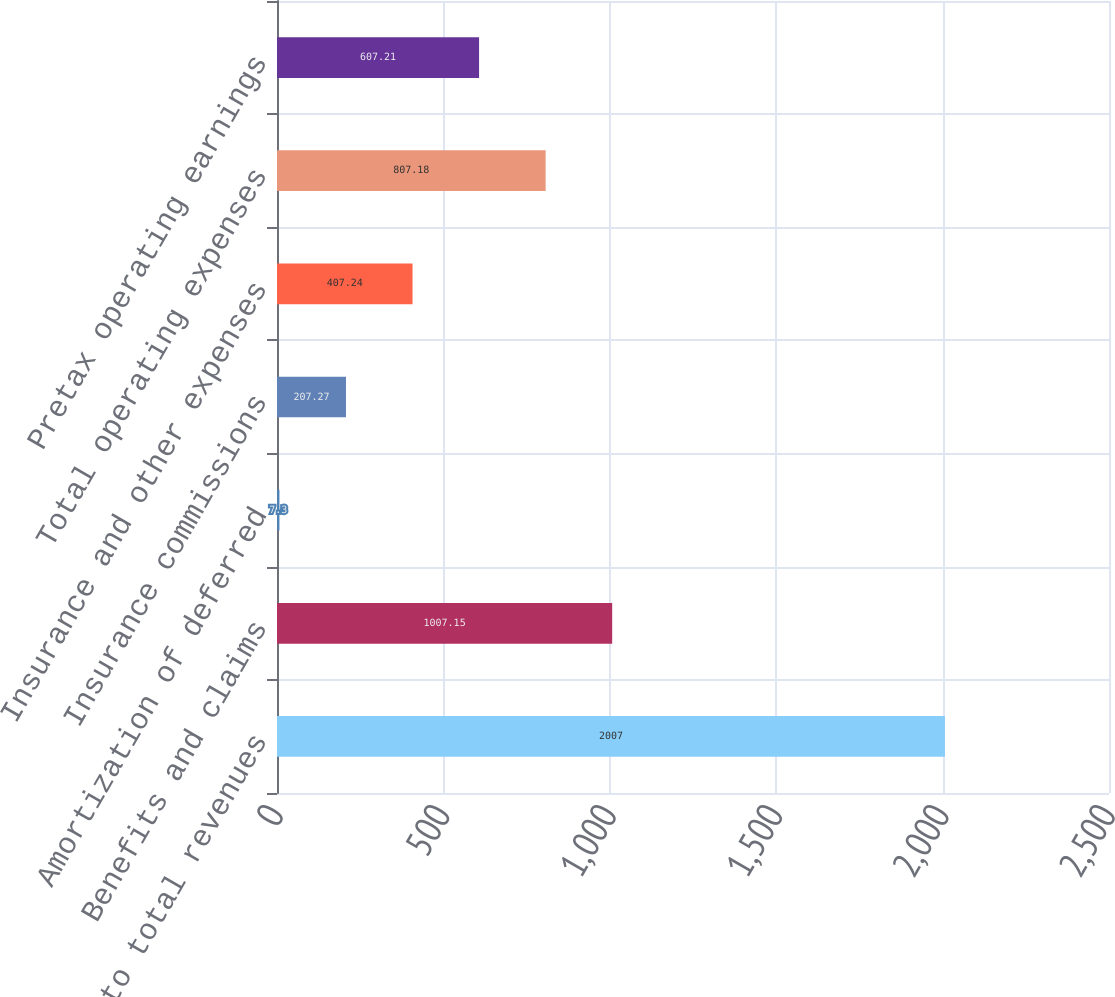Convert chart. <chart><loc_0><loc_0><loc_500><loc_500><bar_chart><fcel>Ratios to total revenues<fcel>Benefits and claims<fcel>Amortization of deferred<fcel>Insurance commissions<fcel>Insurance and other expenses<fcel>Total operating expenses<fcel>Pretax operating earnings<nl><fcel>2007<fcel>1007.15<fcel>7.3<fcel>207.27<fcel>407.24<fcel>807.18<fcel>607.21<nl></chart> 